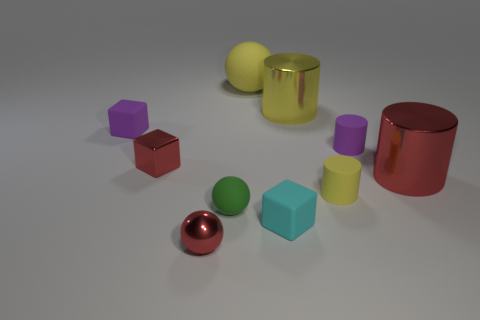Subtract all blocks. How many objects are left? 7 Add 1 purple blocks. How many purple blocks are left? 2 Add 4 cyan rubber things. How many cyan rubber things exist? 5 Subtract 0 blue balls. How many objects are left? 10 Subtract all small purple matte cylinders. Subtract all yellow shiny cylinders. How many objects are left? 8 